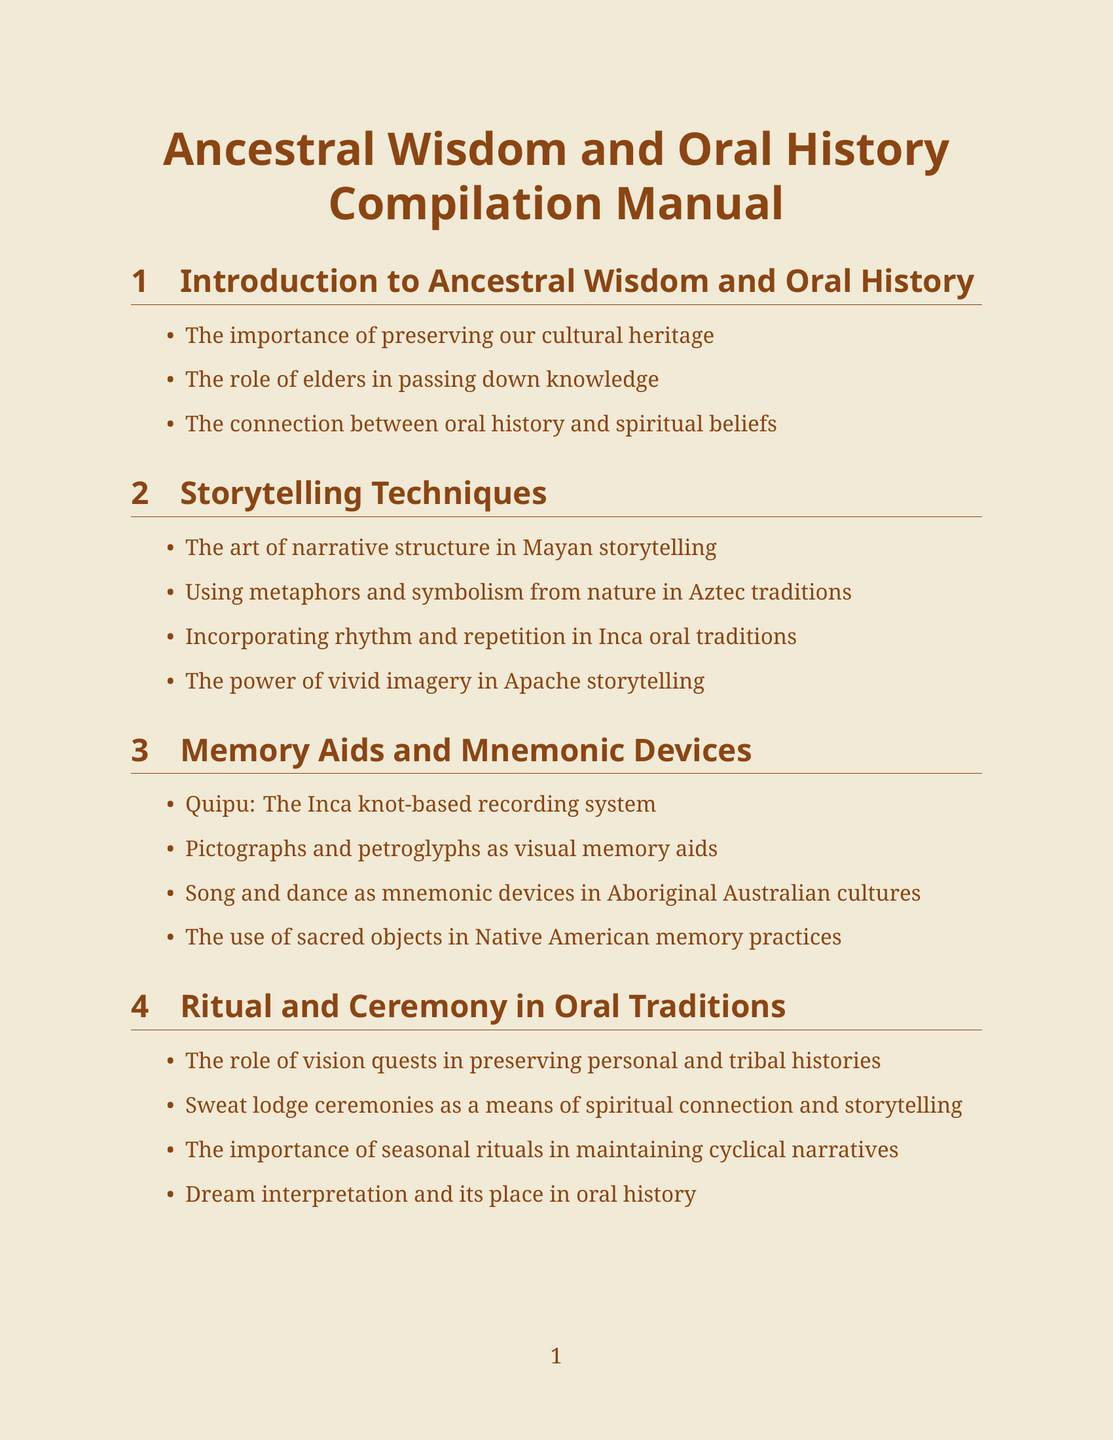What is the title of the manual? The title can be found at the beginning of the document.
Answer: Ancestral Wisdom and Oral History Compilation Manual How many sections are included in the manual? The manual sections are listed clearly; counting them provides the total.
Answer: Eight What technique is associated with Inca oral traditions? The relevant information for each culture is listed in the corresponding section.
Answer: Rhythm and repetition What is Quipu? The manual defines Quipu in the context of memory aids and mnemonic devices.
Answer: The Inca knot-based recording system Which case study explores the Dreamtime stories? The case studies section lists their titles and descriptions.
Answer: The Dreamtime Stories of the Australian Aboriginal Peoples What role do elders play according to the manual? The manual specifies the responsibilities of elders in passing knowledge.
Answer: Passing down knowledge What are medicine wheels categorized as? The resources section lists specific categories and their items.
Answer: Sacred Objects What is emphasized as crucial for future generations? The manual discusses key themes in the teaching section.
Answer: Ancestral Wisdom 